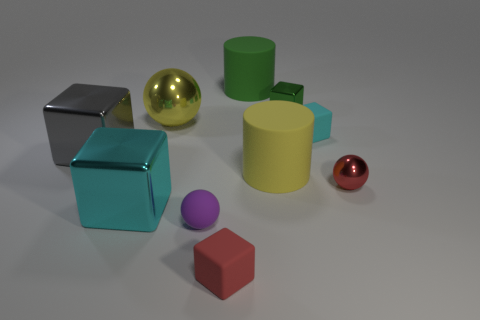There is a big thing that is the same color as the large shiny sphere; what is its shape?
Provide a succinct answer. Cylinder. What number of red things are large metal balls or shiny objects?
Give a very brief answer. 1. There is a green rubber thing; does it have the same size as the cyan block that is left of the tiny green metallic object?
Provide a succinct answer. Yes. There is a small purple object that is the same shape as the large yellow metal object; what is it made of?
Your answer should be very brief. Rubber. What number of other things are the same size as the red cube?
Provide a short and direct response. 4. The large thing that is behind the big metallic sphere to the left of the large cylinder that is left of the yellow rubber cylinder is what shape?
Provide a short and direct response. Cylinder. There is a metal thing that is right of the tiny rubber sphere and left of the red metal ball; what shape is it?
Provide a succinct answer. Cube. What number of things are either red cubes or yellow objects that are behind the small metal sphere?
Keep it short and to the point. 3. Are the red block and the big yellow cylinder made of the same material?
Give a very brief answer. Yes. How many other things are there of the same shape as the tiny cyan object?
Offer a terse response. 4. 